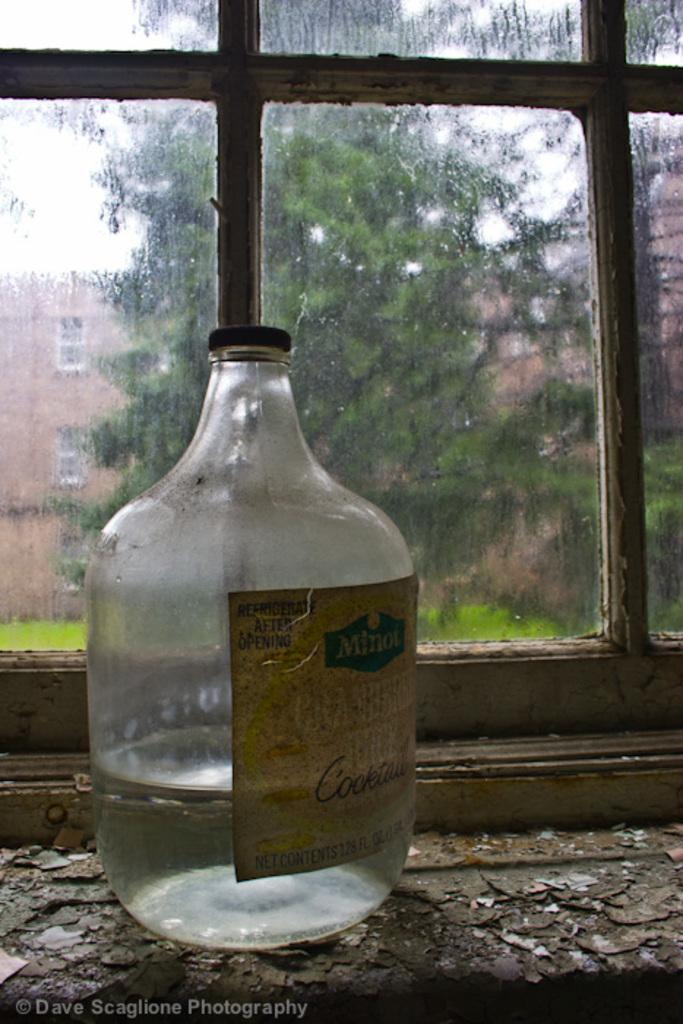Provide a one-sentence caption for the provided image. A jar with liquid in it with a label that says Minot Cocktail on it. 